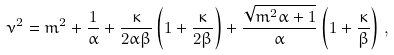<formula> <loc_0><loc_0><loc_500><loc_500>\nu ^ { 2 } = m ^ { 2 } + \frac { 1 } { \alpha } + \frac { \kappa } { 2 \alpha \beta } \left ( 1 + \frac { \kappa } { 2 \beta } \right ) + \frac { \sqrt { m ^ { 2 } \alpha + 1 } } { \alpha } \left ( 1 + \frac { \kappa } { \beta } \right ) \, ,</formula> 